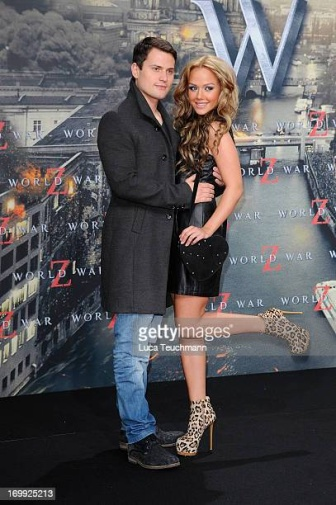Describe the fashion choices of the man and woman. What do their outfits suggest about the occasion? The man is dressed in a formal yet stylish dark gray coat, blue jeans, and black shoes. His outfit blends both comfort and sophistication, suggesting that he is dressed for an important, but not overly formal, event. The woman is wearing a short, elegant black dress that accentuates her figure, paired with eye-catching leopard print high heels. Her attire is glamorous and stylish, indicating that the occasion is likely a special event, such as a movie premiere or a high-profile party. Overall, their fashion choices suggest they are attending an event that requires them to be elegantly dressed while allowing for personal style expression. What do you think is their favourite thing about attending movie premieres? Their favorite thing about attending movie premieres is likely the glamorous atmosphere and the opportunity to dress up and make a fashion statement. They probably enjoy the excitement of being part of an exclusive event, mingling with other attendees, and experiencing the anticipation of a new film's release. The chance to have their pictures taken by the press and to be in the limelight could be another highlight for them, making the whole experience thrilling and memorable. 